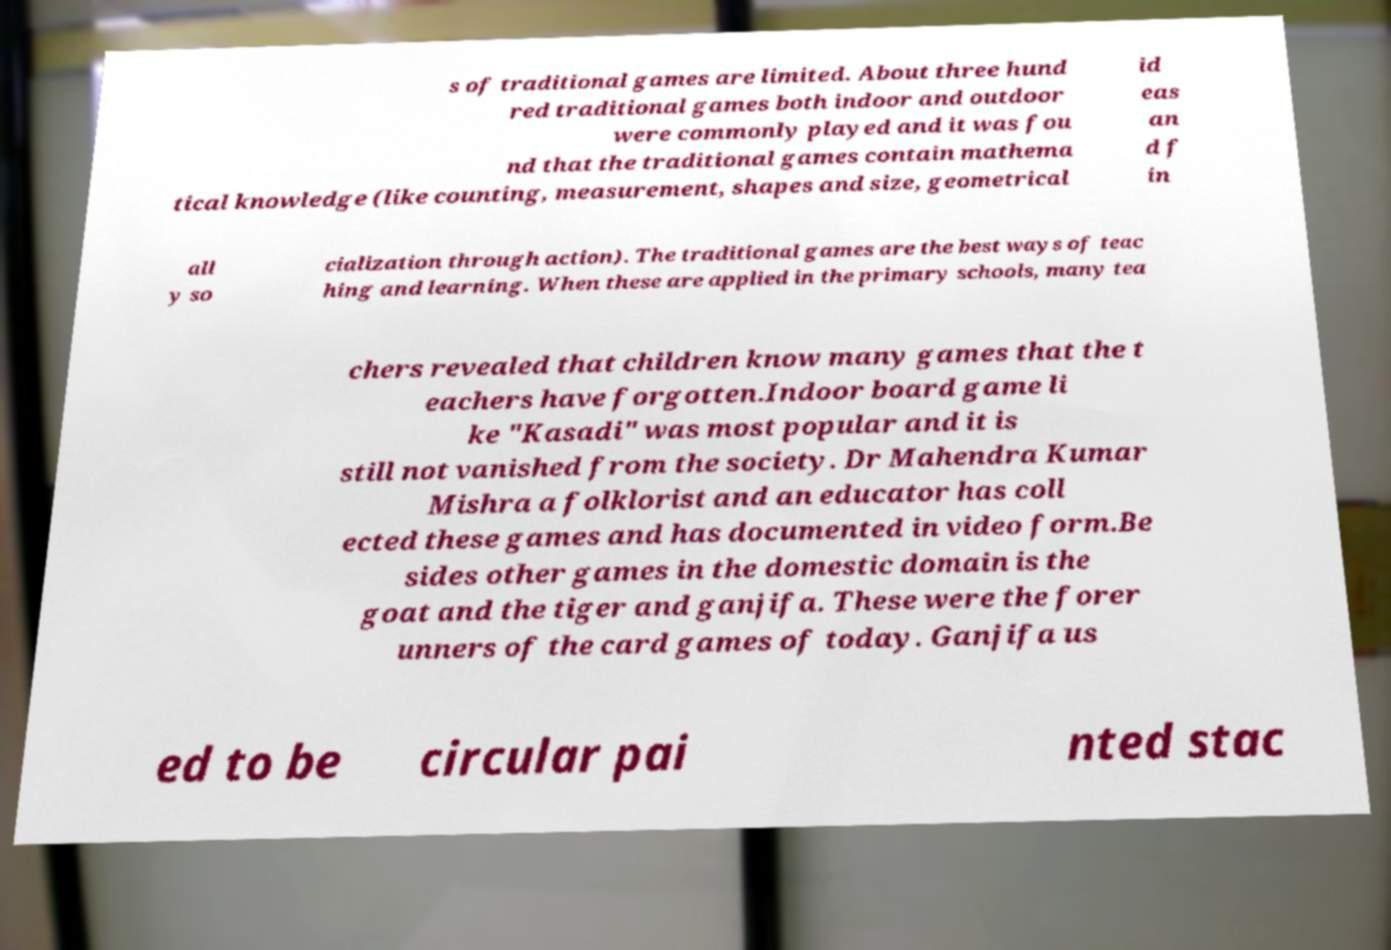I need the written content from this picture converted into text. Can you do that? s of traditional games are limited. About three hund red traditional games both indoor and outdoor were commonly played and it was fou nd that the traditional games contain mathema tical knowledge (like counting, measurement, shapes and size, geometrical id eas an d f in all y so cialization through action). The traditional games are the best ways of teac hing and learning. When these are applied in the primary schools, many tea chers revealed that children know many games that the t eachers have forgotten.Indoor board game li ke "Kasadi" was most popular and it is still not vanished from the society. Dr Mahendra Kumar Mishra a folklorist and an educator has coll ected these games and has documented in video form.Be sides other games in the domestic domain is the goat and the tiger and ganjifa. These were the forer unners of the card games of today. Ganjifa us ed to be circular pai nted stac 